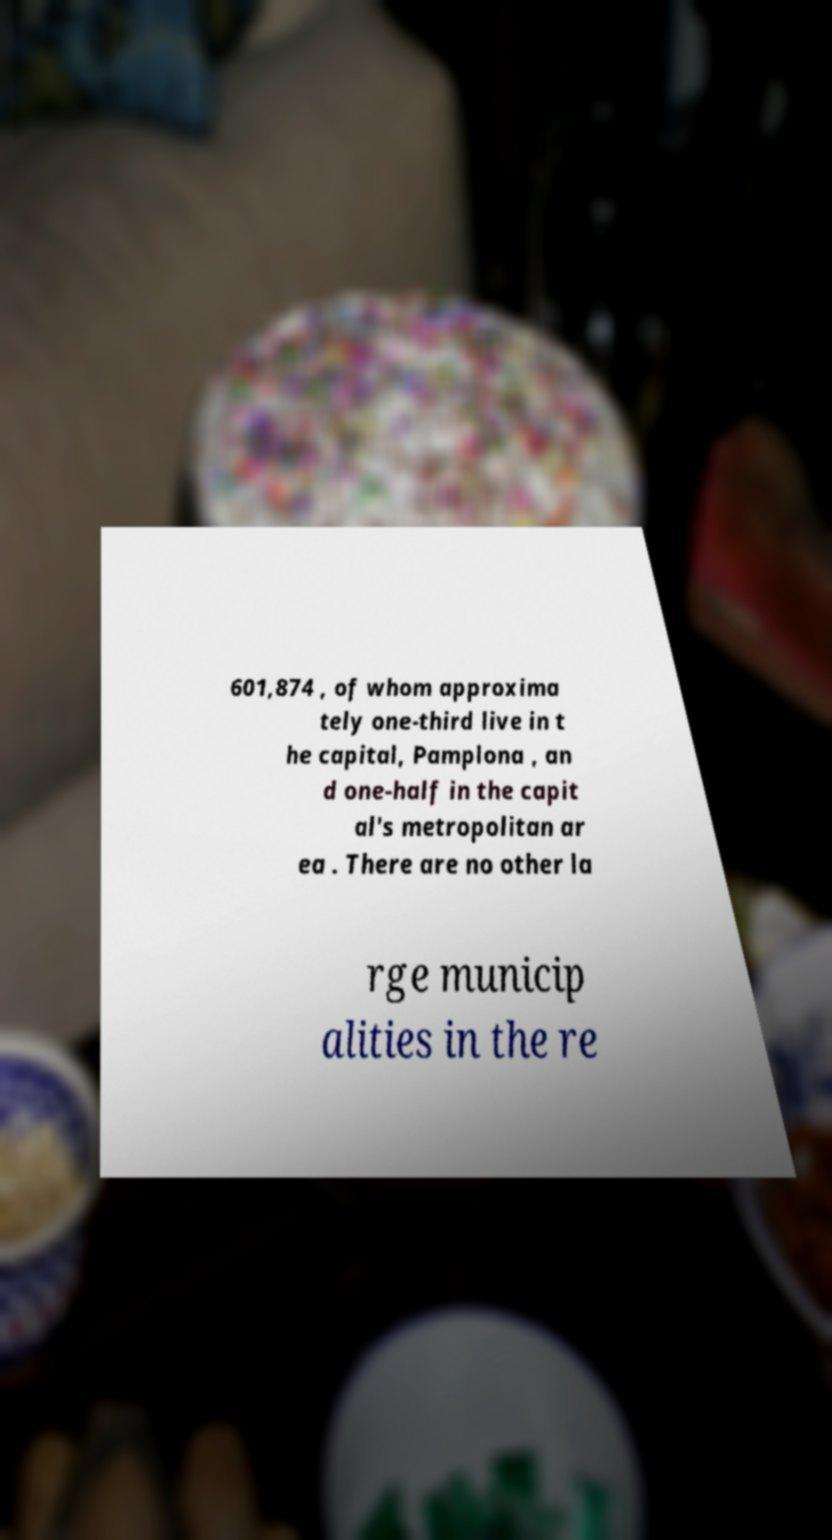Can you accurately transcribe the text from the provided image for me? 601,874 , of whom approxima tely one-third live in t he capital, Pamplona , an d one-half in the capit al's metropolitan ar ea . There are no other la rge municip alities in the re 